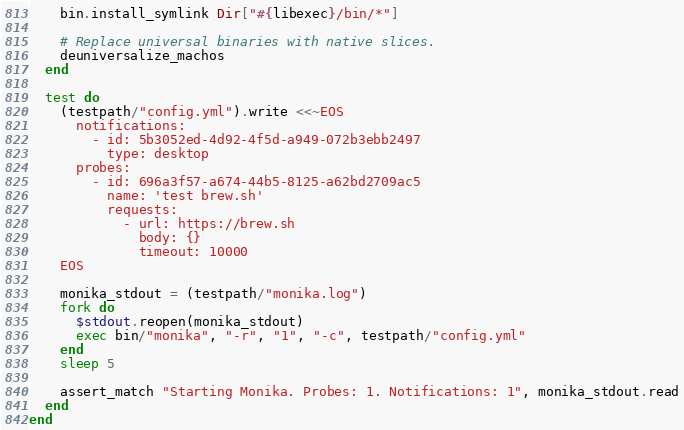Convert code to text. <code><loc_0><loc_0><loc_500><loc_500><_Ruby_>    bin.install_symlink Dir["#{libexec}/bin/*"]

    # Replace universal binaries with native slices.
    deuniversalize_machos
  end

  test do
    (testpath/"config.yml").write <<~EOS
      notifications:
        - id: 5b3052ed-4d92-4f5d-a949-072b3ebb2497
          type: desktop
      probes:
        - id: 696a3f57-a674-44b5-8125-a62bd2709ac5
          name: 'test brew.sh'
          requests:
            - url: https://brew.sh
              body: {}
              timeout: 10000
    EOS

    monika_stdout = (testpath/"monika.log")
    fork do
      $stdout.reopen(monika_stdout)
      exec bin/"monika", "-r", "1", "-c", testpath/"config.yml"
    end
    sleep 5

    assert_match "Starting Monika. Probes: 1. Notifications: 1", monika_stdout.read
  end
end
</code> 